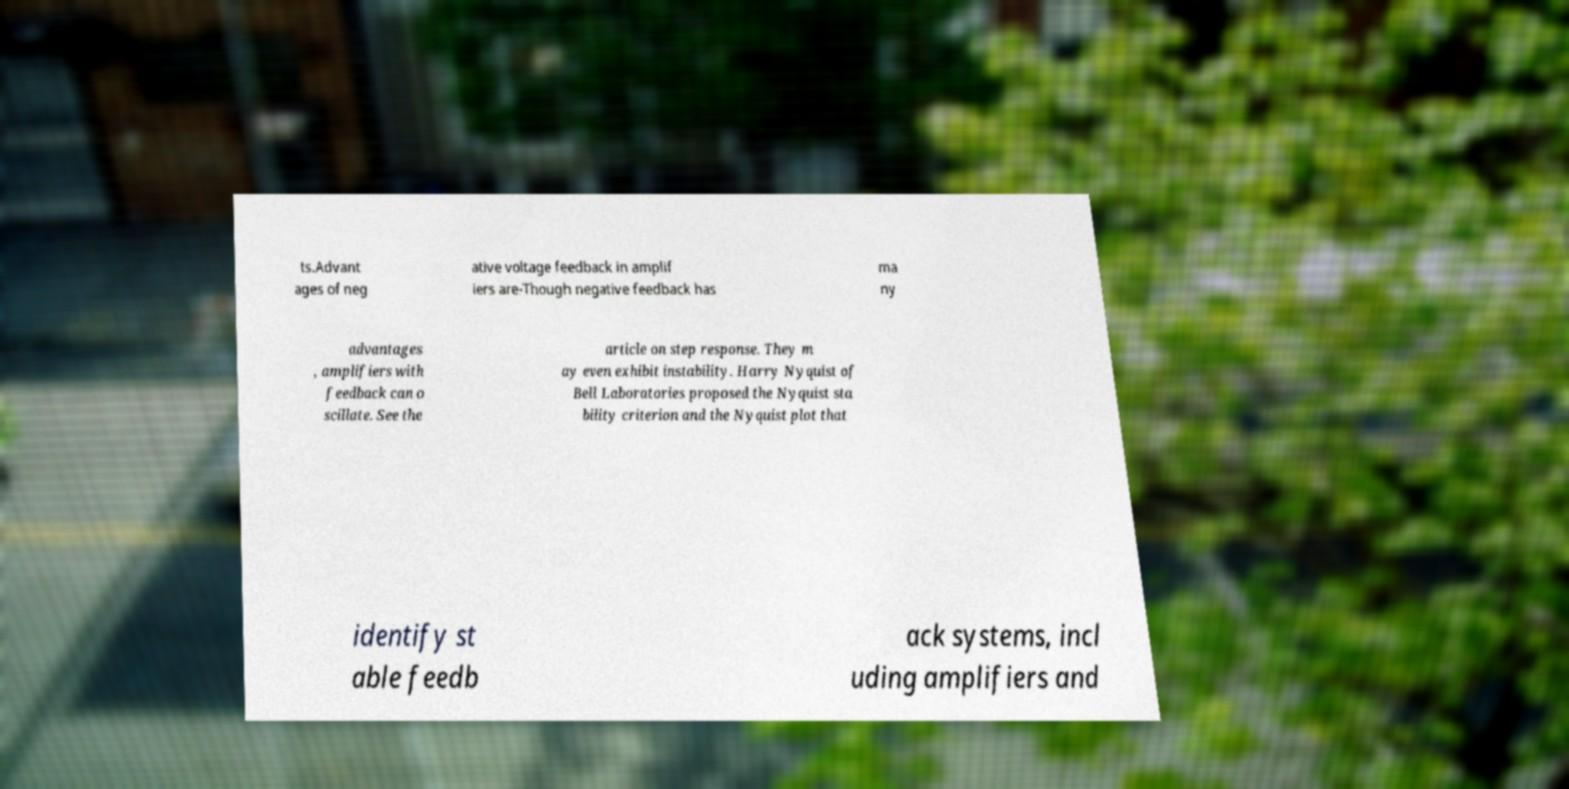For documentation purposes, I need the text within this image transcribed. Could you provide that? ts.Advant ages of neg ative voltage feedback in amplif iers are-Though negative feedback has ma ny advantages , amplifiers with feedback can o scillate. See the article on step response. They m ay even exhibit instability. Harry Nyquist of Bell Laboratories proposed the Nyquist sta bility criterion and the Nyquist plot that identify st able feedb ack systems, incl uding amplifiers and 